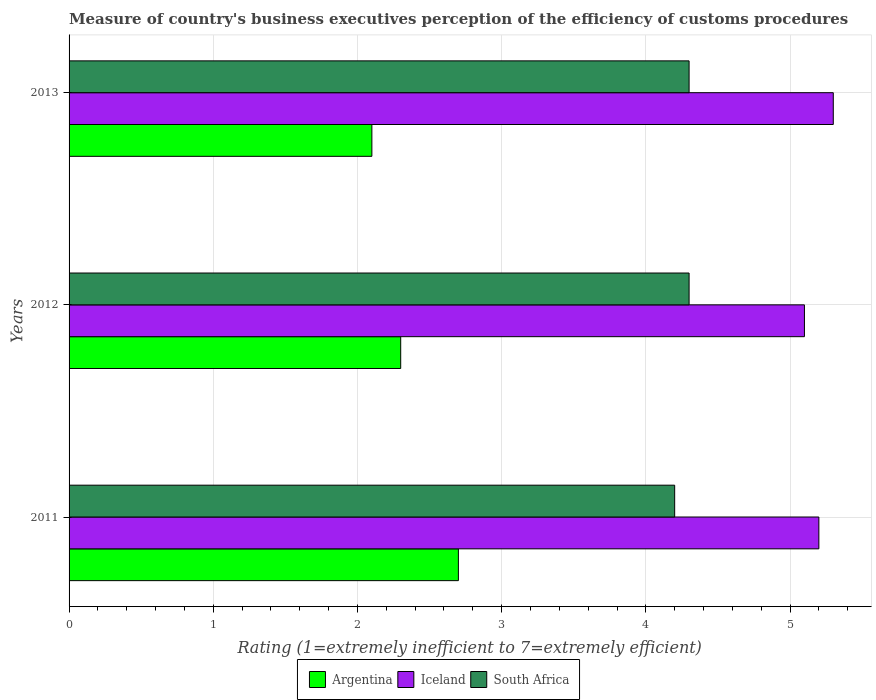How many different coloured bars are there?
Give a very brief answer. 3. How many groups of bars are there?
Your answer should be compact. 3. Are the number of bars on each tick of the Y-axis equal?
Offer a very short reply. Yes. Across all years, what is the minimum rating of the efficiency of customs procedure in South Africa?
Provide a short and direct response. 4.2. In which year was the rating of the efficiency of customs procedure in South Africa maximum?
Your answer should be compact. 2012. In which year was the rating of the efficiency of customs procedure in South Africa minimum?
Offer a terse response. 2011. What is the total rating of the efficiency of customs procedure in Iceland in the graph?
Give a very brief answer. 15.6. What is the difference between the rating of the efficiency of customs procedure in Iceland in 2011 and that in 2012?
Your answer should be compact. 0.1. What is the difference between the rating of the efficiency of customs procedure in Iceland in 2011 and the rating of the efficiency of customs procedure in Argentina in 2012?
Provide a short and direct response. 2.9. In the year 2013, what is the difference between the rating of the efficiency of customs procedure in Iceland and rating of the efficiency of customs procedure in Argentina?
Provide a short and direct response. 3.2. In how many years, is the rating of the efficiency of customs procedure in South Africa greater than 4.4 ?
Your response must be concise. 0. Is the rating of the efficiency of customs procedure in Argentina in 2011 less than that in 2012?
Provide a succinct answer. No. What is the difference between the highest and the second highest rating of the efficiency of customs procedure in Argentina?
Provide a succinct answer. 0.4. What is the difference between the highest and the lowest rating of the efficiency of customs procedure in Argentina?
Provide a short and direct response. 0.6. What does the 1st bar from the top in 2012 represents?
Provide a succinct answer. South Africa. What does the 2nd bar from the bottom in 2012 represents?
Provide a short and direct response. Iceland. Are the values on the major ticks of X-axis written in scientific E-notation?
Give a very brief answer. No. Does the graph contain any zero values?
Keep it short and to the point. No. Does the graph contain grids?
Your answer should be very brief. Yes. How are the legend labels stacked?
Offer a terse response. Horizontal. What is the title of the graph?
Your answer should be very brief. Measure of country's business executives perception of the efficiency of customs procedures. What is the label or title of the X-axis?
Provide a succinct answer. Rating (1=extremely inefficient to 7=extremely efficient). What is the Rating (1=extremely inefficient to 7=extremely efficient) in Argentina in 2011?
Offer a terse response. 2.7. What is the Rating (1=extremely inefficient to 7=extremely efficient) in Iceland in 2013?
Ensure brevity in your answer.  5.3. Across all years, what is the maximum Rating (1=extremely inefficient to 7=extremely efficient) in Argentina?
Keep it short and to the point. 2.7. Across all years, what is the maximum Rating (1=extremely inefficient to 7=extremely efficient) of Iceland?
Offer a terse response. 5.3. Across all years, what is the minimum Rating (1=extremely inefficient to 7=extremely efficient) in Argentina?
Ensure brevity in your answer.  2.1. What is the total Rating (1=extremely inefficient to 7=extremely efficient) of South Africa in the graph?
Your answer should be compact. 12.8. What is the difference between the Rating (1=extremely inefficient to 7=extremely efficient) of South Africa in 2011 and that in 2013?
Your answer should be very brief. -0.1. What is the difference between the Rating (1=extremely inefficient to 7=extremely efficient) of Argentina in 2012 and that in 2013?
Your answer should be very brief. 0.2. What is the difference between the Rating (1=extremely inefficient to 7=extremely efficient) of South Africa in 2012 and that in 2013?
Your answer should be compact. 0. What is the difference between the Rating (1=extremely inefficient to 7=extremely efficient) of Argentina in 2011 and the Rating (1=extremely inefficient to 7=extremely efficient) of Iceland in 2012?
Make the answer very short. -2.4. What is the difference between the Rating (1=extremely inefficient to 7=extremely efficient) of Iceland in 2011 and the Rating (1=extremely inefficient to 7=extremely efficient) of South Africa in 2012?
Make the answer very short. 0.9. What is the difference between the Rating (1=extremely inefficient to 7=extremely efficient) in Argentina in 2011 and the Rating (1=extremely inefficient to 7=extremely efficient) in Iceland in 2013?
Offer a terse response. -2.6. What is the difference between the Rating (1=extremely inefficient to 7=extremely efficient) in Argentina in 2012 and the Rating (1=extremely inefficient to 7=extremely efficient) in Iceland in 2013?
Provide a succinct answer. -3. What is the difference between the Rating (1=extremely inefficient to 7=extremely efficient) of Argentina in 2012 and the Rating (1=extremely inefficient to 7=extremely efficient) of South Africa in 2013?
Your answer should be compact. -2. What is the difference between the Rating (1=extremely inefficient to 7=extremely efficient) in Iceland in 2012 and the Rating (1=extremely inefficient to 7=extremely efficient) in South Africa in 2013?
Provide a short and direct response. 0.8. What is the average Rating (1=extremely inefficient to 7=extremely efficient) of Argentina per year?
Make the answer very short. 2.37. What is the average Rating (1=extremely inefficient to 7=extremely efficient) of Iceland per year?
Provide a short and direct response. 5.2. What is the average Rating (1=extremely inefficient to 7=extremely efficient) of South Africa per year?
Make the answer very short. 4.27. In the year 2011, what is the difference between the Rating (1=extremely inefficient to 7=extremely efficient) in Argentina and Rating (1=extremely inefficient to 7=extremely efficient) in South Africa?
Provide a succinct answer. -1.5. In the year 2011, what is the difference between the Rating (1=extremely inefficient to 7=extremely efficient) in Iceland and Rating (1=extremely inefficient to 7=extremely efficient) in South Africa?
Make the answer very short. 1. In the year 2012, what is the difference between the Rating (1=extremely inefficient to 7=extremely efficient) in Argentina and Rating (1=extremely inefficient to 7=extremely efficient) in Iceland?
Keep it short and to the point. -2.8. In the year 2013, what is the difference between the Rating (1=extremely inefficient to 7=extremely efficient) of Argentina and Rating (1=extremely inefficient to 7=extremely efficient) of Iceland?
Ensure brevity in your answer.  -3.2. What is the ratio of the Rating (1=extremely inefficient to 7=extremely efficient) of Argentina in 2011 to that in 2012?
Your response must be concise. 1.17. What is the ratio of the Rating (1=extremely inefficient to 7=extremely efficient) in Iceland in 2011 to that in 2012?
Make the answer very short. 1.02. What is the ratio of the Rating (1=extremely inefficient to 7=extremely efficient) of South Africa in 2011 to that in 2012?
Offer a very short reply. 0.98. What is the ratio of the Rating (1=extremely inefficient to 7=extremely efficient) in Iceland in 2011 to that in 2013?
Give a very brief answer. 0.98. What is the ratio of the Rating (1=extremely inefficient to 7=extremely efficient) of South Africa in 2011 to that in 2013?
Ensure brevity in your answer.  0.98. What is the ratio of the Rating (1=extremely inefficient to 7=extremely efficient) of Argentina in 2012 to that in 2013?
Offer a very short reply. 1.1. What is the ratio of the Rating (1=extremely inefficient to 7=extremely efficient) of Iceland in 2012 to that in 2013?
Give a very brief answer. 0.96. What is the ratio of the Rating (1=extremely inefficient to 7=extremely efficient) in South Africa in 2012 to that in 2013?
Keep it short and to the point. 1. What is the difference between the highest and the second highest Rating (1=extremely inefficient to 7=extremely efficient) of South Africa?
Offer a very short reply. 0. What is the difference between the highest and the lowest Rating (1=extremely inefficient to 7=extremely efficient) in Iceland?
Provide a succinct answer. 0.2. What is the difference between the highest and the lowest Rating (1=extremely inefficient to 7=extremely efficient) in South Africa?
Provide a short and direct response. 0.1. 